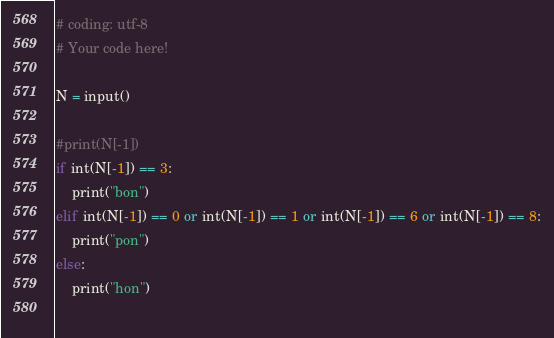Convert code to text. <code><loc_0><loc_0><loc_500><loc_500><_Python_># coding: utf-8
# Your code here!

N = input()

#print(N[-1])
if int(N[-1]) == 3:
    print("bon")
elif int(N[-1]) == 0 or int(N[-1]) == 1 or int(N[-1]) == 6 or int(N[-1]) == 8:
    print("pon")
else:
    print("hon")
    </code> 